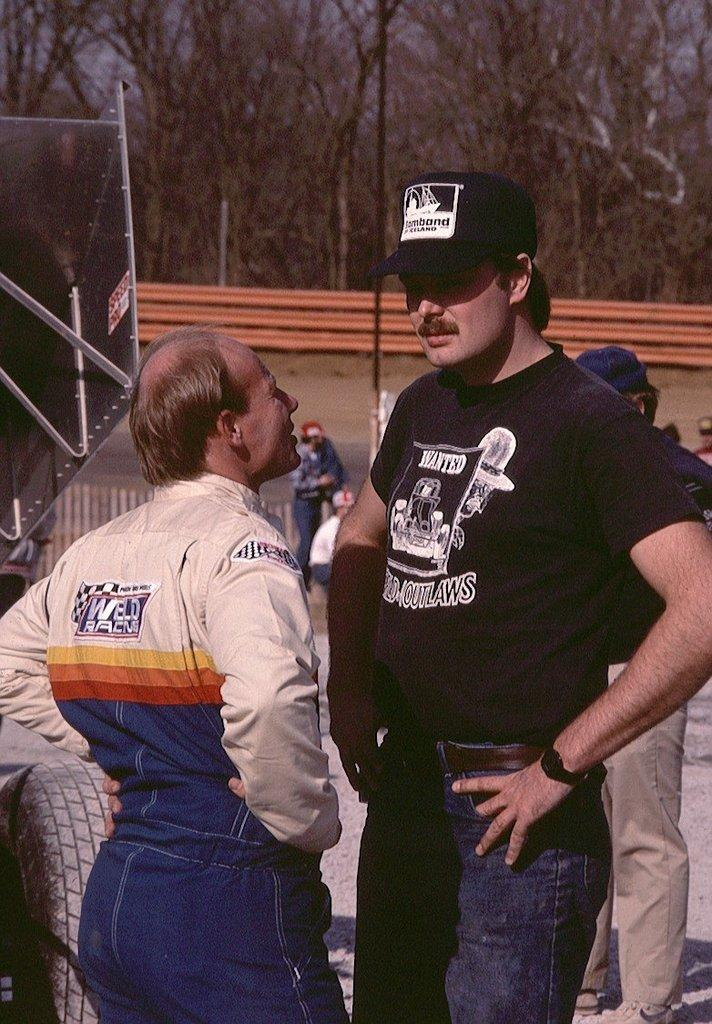What are the people in the image doing? The people in the image are standing on the road. What type of vehicle can be seen in the image? There is a motor vehicle in the image. What architectural features are visible in the image? Walls are visible in the image. What type of vegetation is present in the image? Trees are present in the image. What part of the natural environment is visible in the image? The sky is visible in the image. Can you see a bear playing on a swing in the image? No, there is no bear or swing present in the image. How many fingers does the person in the image have? The image does not provide enough detail to determine the number of fingers on the person's hand. 